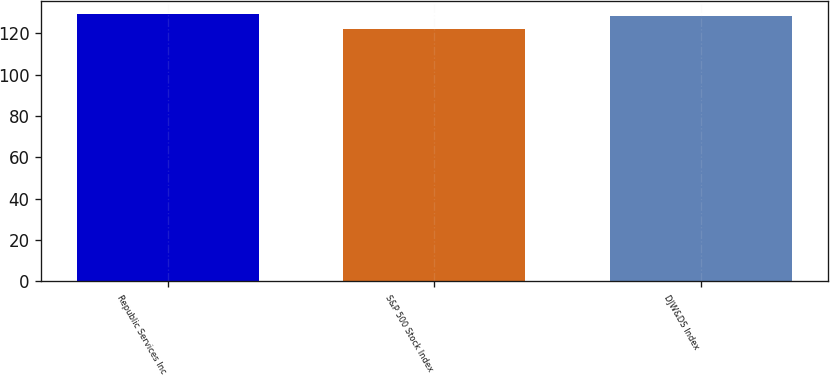<chart> <loc_0><loc_0><loc_500><loc_500><bar_chart><fcel>Republic Services Inc<fcel>S&P 500 Stock Index<fcel>DJW&DS Index<nl><fcel>129.38<fcel>122.16<fcel>128.5<nl></chart> 